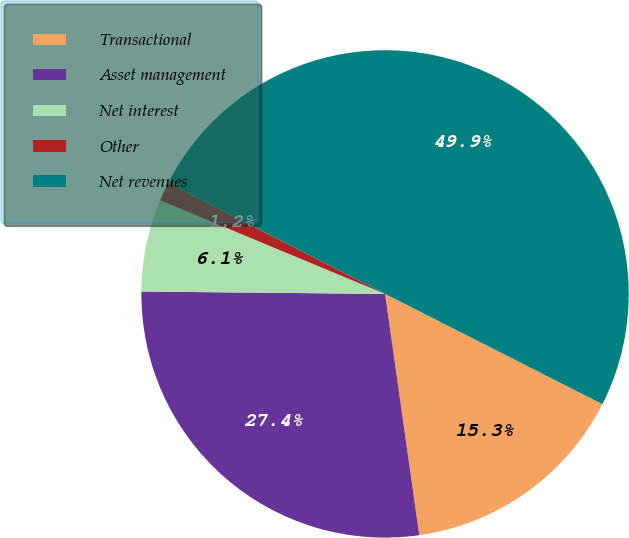Convert chart to OTSL. <chart><loc_0><loc_0><loc_500><loc_500><pie_chart><fcel>Transactional<fcel>Asset management<fcel>Net interest<fcel>Other<fcel>Net revenues<nl><fcel>15.29%<fcel>27.4%<fcel>6.12%<fcel>1.25%<fcel>49.95%<nl></chart> 